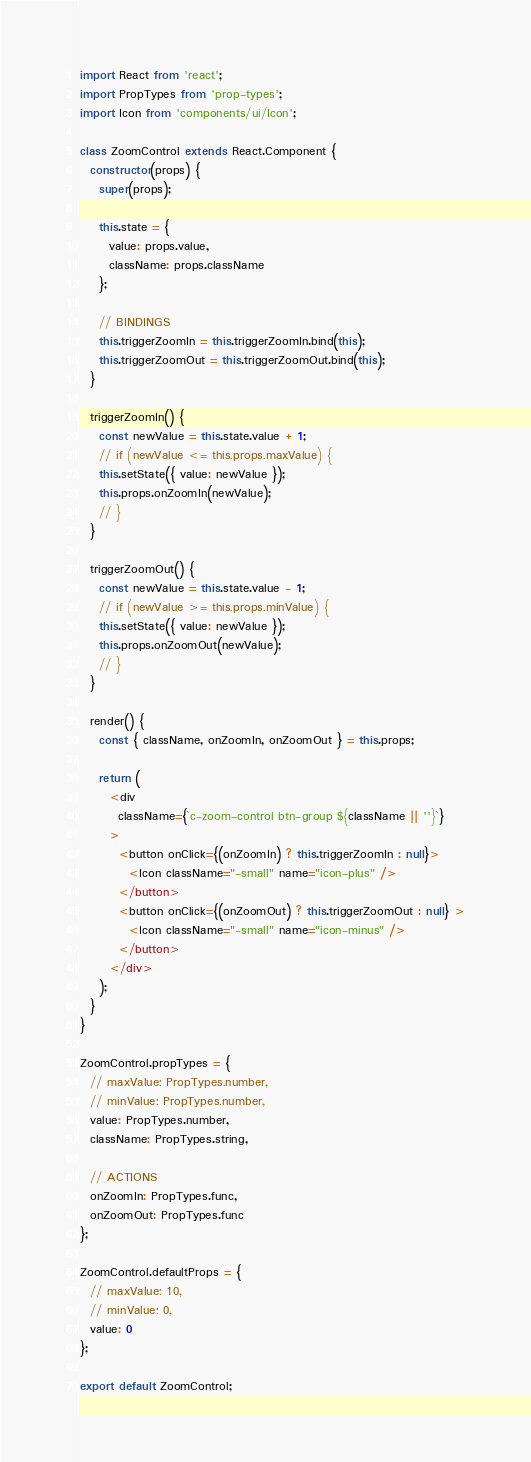<code> <loc_0><loc_0><loc_500><loc_500><_JavaScript_>import React from 'react';
import PropTypes from 'prop-types';
import Icon from 'components/ui/Icon';

class ZoomControl extends React.Component {
  constructor(props) {
    super(props);

    this.state = {
      value: props.value,
      className: props.className
    };

    // BINDINGS
    this.triggerZoomIn = this.triggerZoomIn.bind(this);
    this.triggerZoomOut = this.triggerZoomOut.bind(this);
  }

  triggerZoomIn() {
    const newValue = this.state.value + 1;
    // if (newValue <= this.props.maxValue) {
    this.setState({ value: newValue });
    this.props.onZoomIn(newValue);
    // }
  }

  triggerZoomOut() {
    const newValue = this.state.value - 1;
    // if (newValue >= this.props.minValue) {
    this.setState({ value: newValue });
    this.props.onZoomOut(newValue);
    // }
  }

  render() {
    const { className, onZoomIn, onZoomOut } = this.props;

    return (
      <div
        className={`c-zoom-control btn-group ${className || ''}`}
      >
        <button onClick={(onZoomIn) ? this.triggerZoomIn : null}>
          <Icon className="-small" name="icon-plus" />
        </button>
        <button onClick={(onZoomOut) ? this.triggerZoomOut : null} >
          <Icon className="-small" name="icon-minus" />
        </button>
      </div>
    );
  }
}

ZoomControl.propTypes = {
  // maxValue: PropTypes.number,
  // minValue: PropTypes.number,
  value: PropTypes.number,
  className: PropTypes.string,

  // ACTIONS
  onZoomIn: PropTypes.func,
  onZoomOut: PropTypes.func
};

ZoomControl.defaultProps = {
  // maxValue: 10,
  // minValue: 0,
  value: 0
};

export default ZoomControl;
</code> 